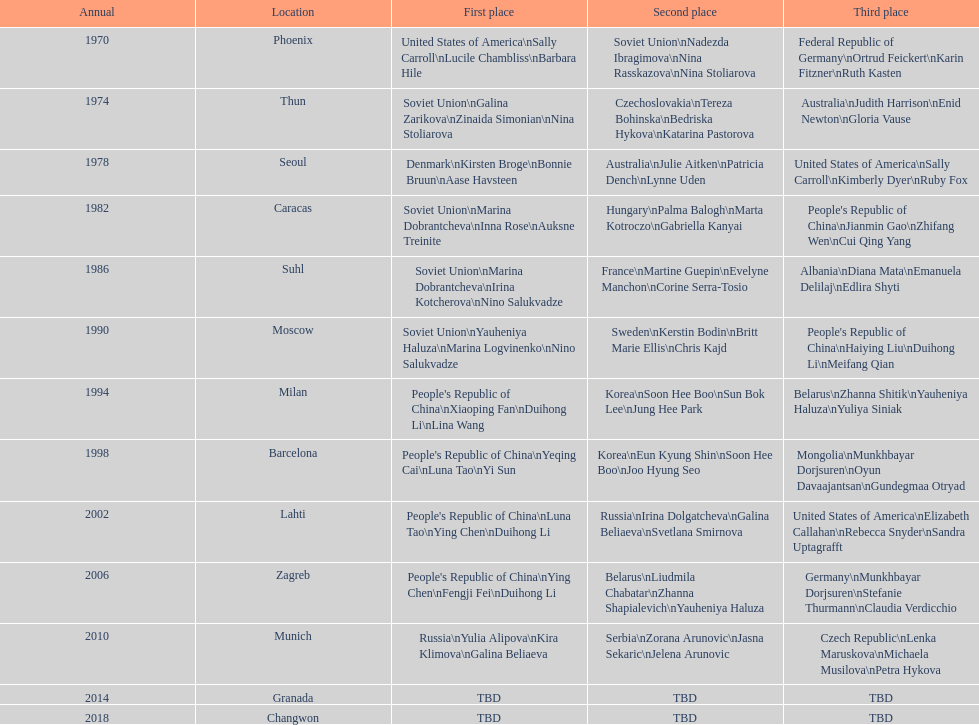How many times has germany won bronze? 2. 